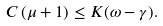<formula> <loc_0><loc_0><loc_500><loc_500>C \left ( \mu + 1 \right ) \leq K ( \omega - \gamma ) .</formula> 